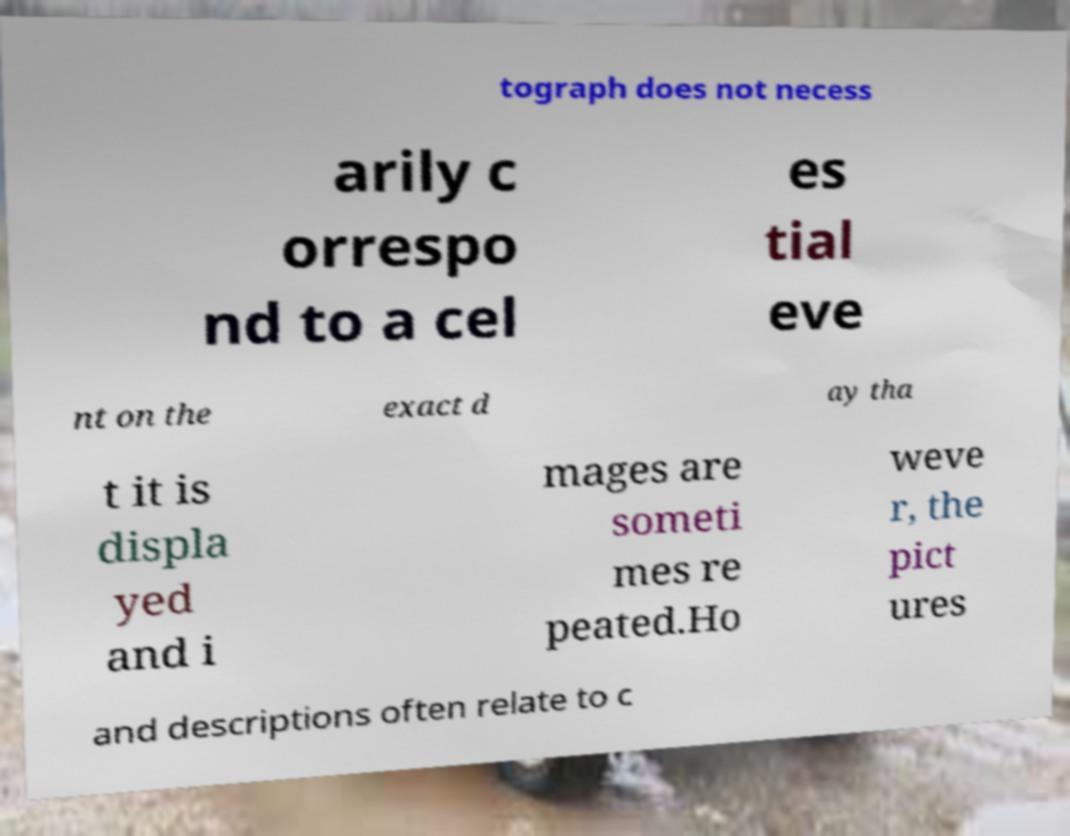Can you read and provide the text displayed in the image?This photo seems to have some interesting text. Can you extract and type it out for me? tograph does not necess arily c orrespo nd to a cel es tial eve nt on the exact d ay tha t it is displa yed and i mages are someti mes re peated.Ho weve r, the pict ures and descriptions often relate to c 